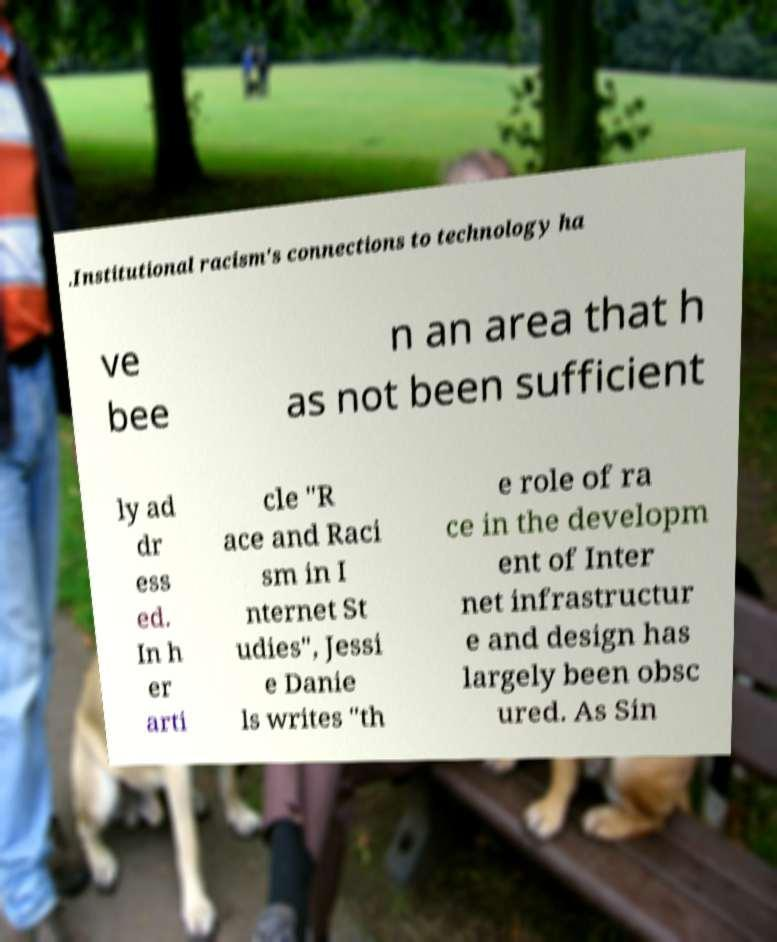I need the written content from this picture converted into text. Can you do that? .Institutional racism's connections to technology ha ve bee n an area that h as not been sufficient ly ad dr ess ed. In h er arti cle "R ace and Raci sm in I nternet St udies", Jessi e Danie ls writes "th e role of ra ce in the developm ent of Inter net infrastructur e and design has largely been obsc ured. As Sin 